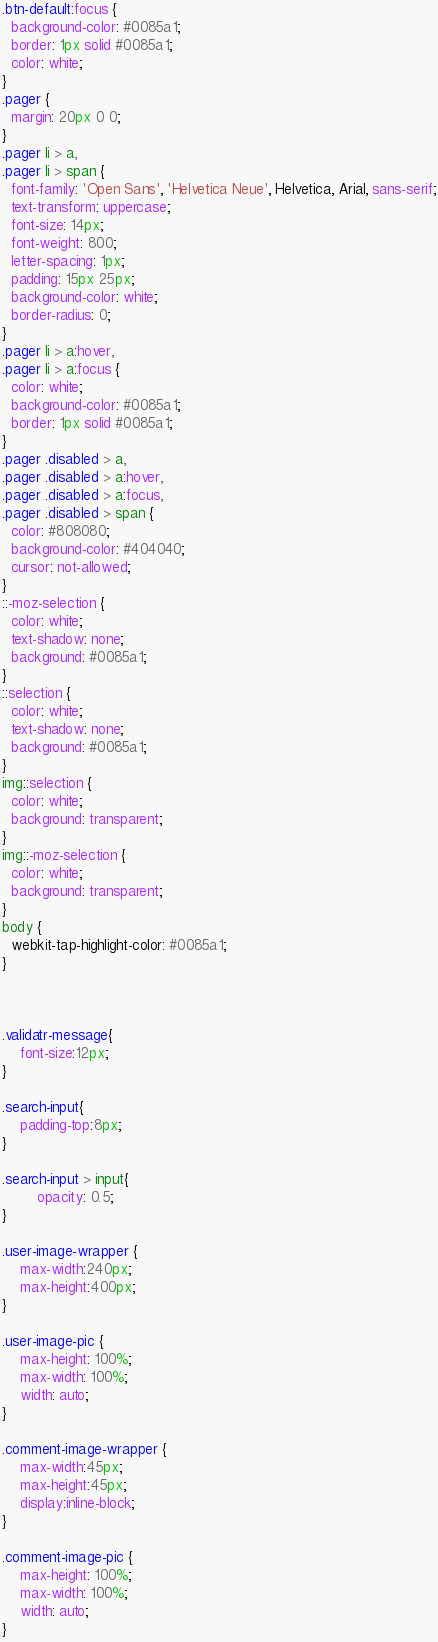Convert code to text. <code><loc_0><loc_0><loc_500><loc_500><_CSS_>.btn-default:focus {
  background-color: #0085a1;
  border: 1px solid #0085a1;
  color: white;
}
.pager {
  margin: 20px 0 0;
}
.pager li > a,
.pager li > span {
  font-family: 'Open Sans', 'Helvetica Neue', Helvetica, Arial, sans-serif;
  text-transform: uppercase;
  font-size: 14px;
  font-weight: 800;
  letter-spacing: 1px;
  padding: 15px 25px;
  background-color: white;
  border-radius: 0;
}
.pager li > a:hover,
.pager li > a:focus {
  color: white;
  background-color: #0085a1;
  border: 1px solid #0085a1;
}
.pager .disabled > a,
.pager .disabled > a:hover,
.pager .disabled > a:focus,
.pager .disabled > span {
  color: #808080;
  background-color: #404040;
  cursor: not-allowed;
}
::-moz-selection {
  color: white;
  text-shadow: none;
  background: #0085a1;
}
::selection {
  color: white;
  text-shadow: none;
  background: #0085a1;
}
img::selection {
  color: white;
  background: transparent;
}
img::-moz-selection {
  color: white;
  background: transparent;
}
body {
  webkit-tap-highlight-color: #0085a1;
}



.validatr-message{
    font-size:12px;
}

.search-input{
    padding-top:8px;
}

.search-input > input{
    	opacity: 0.5;
}

.user-image-wrapper {
    max-width:240px;
    max-height:400px;
}

.user-image-pic {
    max-height: 100%;
    max-width: 100%;
    width: auto;
}

.comment-image-wrapper {
    max-width:45px;
    max-height:45px;
    display:inline-block;
}

.comment-image-pic {
    max-height: 100%;
    max-width: 100%;
    width: auto;
}
</code> 